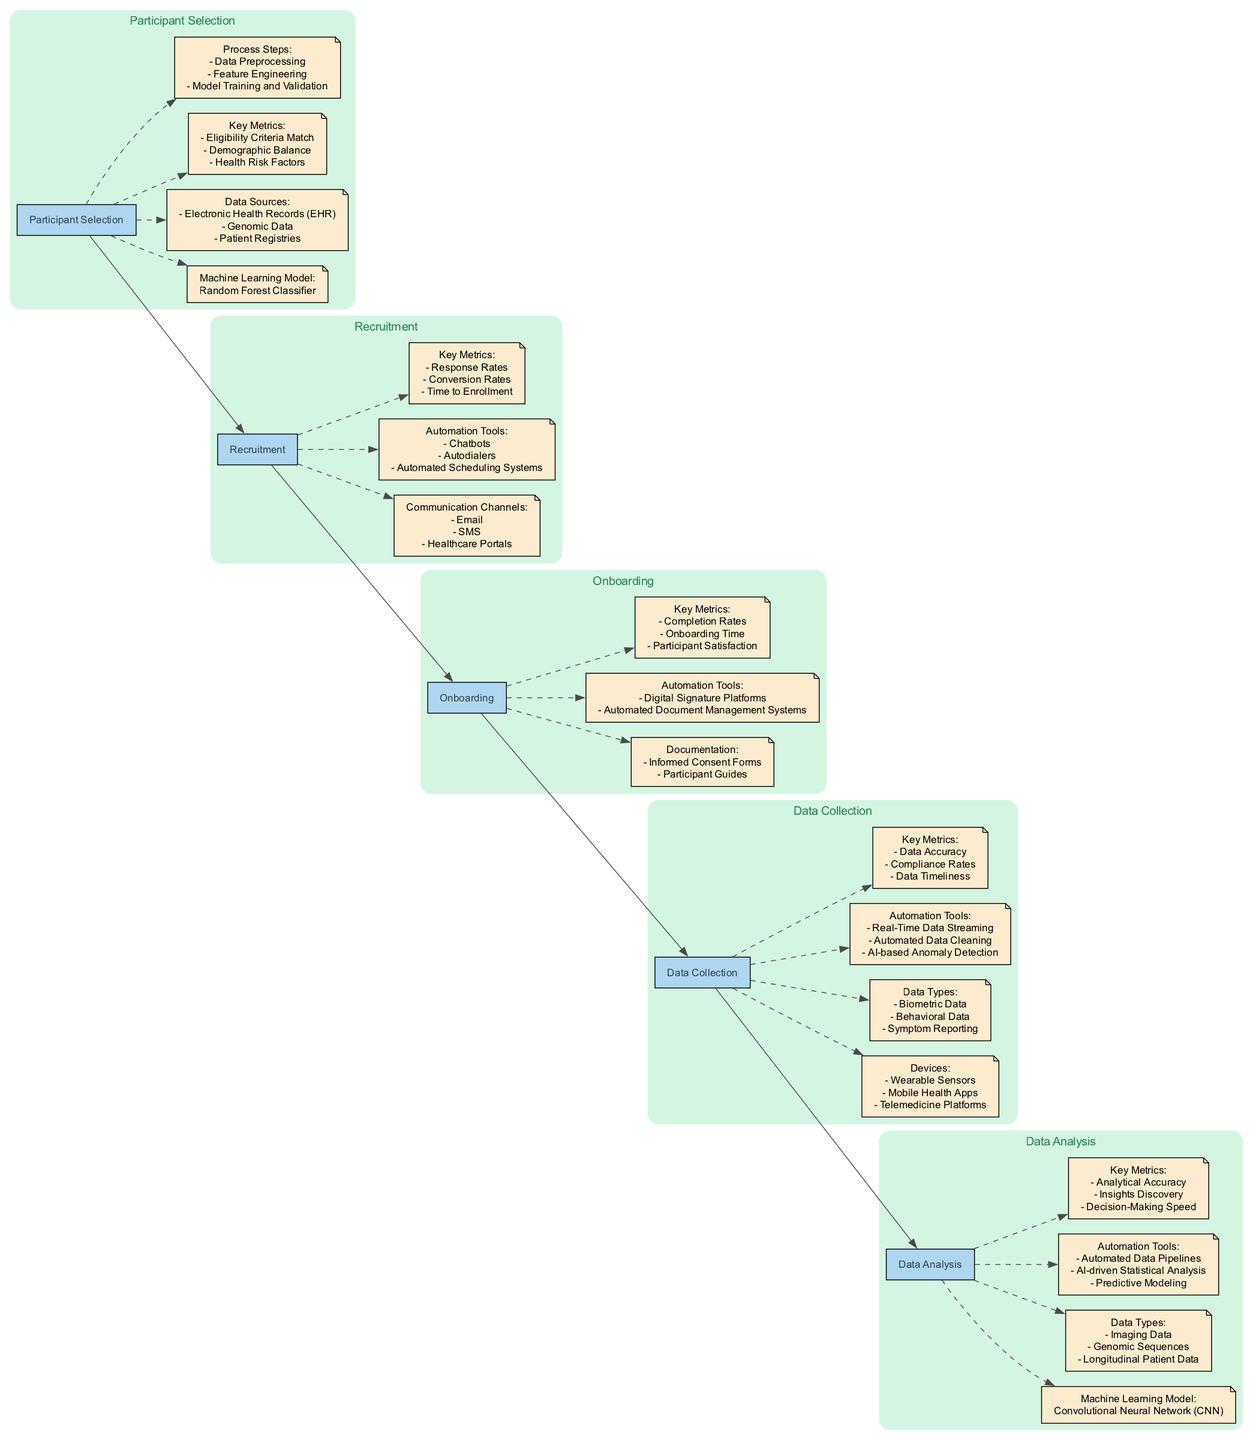What is the primary machine learning model used for participant selection? The diagram specifically indicates that the primary machine learning model used for participant selection is the Random Forest Classifier. This information is highlighted in the participant selection section of the diagram.
Answer: Random Forest Classifier Which automation tool is listed for data collection? In the data collection section of the diagram, one of the automation tools listed is the AI-based Anomaly Detection. This tool is part of the automation tools that optimize the data collection process.
Answer: AI-based Anomaly Detection How many communication channels are mentioned in the recruitment step? The recruitment section of the diagram indicates three communication channels: Email, SMS, and Healthcare Portals. Therefore, the count of communication channels is three.
Answer: 3 What are the key metrics concerning onboarding? The diagram outlines three key metrics related to onboarding: Completion Rates, Onboarding Time, and Participant Satisfaction. It specifies these metrics directly under the onboarding section.
Answer: Completion Rates, Onboarding Time, Participant Satisfaction What kind of data does the data analysis step utilize? The data analysis section of the diagram lists three types of data: Imaging Data, Genomic Sequences, and Longitudinal Patient Data. This categorization shows the data types relevant to analysis in clinical trials.
Answer: Imaging Data, Genomic Sequences, Longitudinal Patient Data Which step directly follows participant selection? According to the flow of the diagram, the step that follows participant selection is recruitment. This sequential relationship is clear from the connections indicated in the diagram.
Answer: Recruitment What is the purpose of the automation tools listed under onboarding? The diagram specifies that the automation tools under onboarding, specifically Digital Signature Platforms and Automated Document Management Systems, are intended to streamline the onboarding process. The automation helps facilitate documentation and reduce manual errors.
Answer: Streamline the onboarding process What is the last step in the clinical pathway? The last step in the clinical pathway, as indicated by the flow in the diagram, is data analysis. This is the final process where various forms of data are examined for insights.
Answer: Data Analysis 